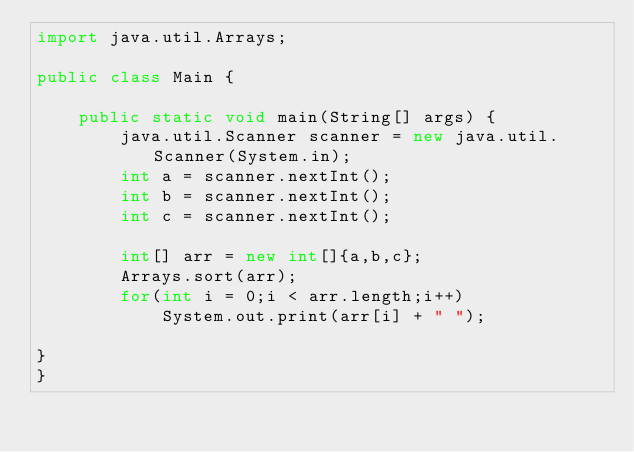<code> <loc_0><loc_0><loc_500><loc_500><_Java_>import java.util.Arrays;

public class Main {

	public static void main(String[] args) {
		java.util.Scanner scanner = new java.util.Scanner(System.in);
		int a = scanner.nextInt();
		int b = scanner.nextInt();
		int c = scanner.nextInt();
		
		int[] arr = new int[]{a,b,c};
		Arrays.sort(arr);
		for(int i = 0;i < arr.length;i++)
			System.out.print(arr[i] + " ");

}
}</code> 